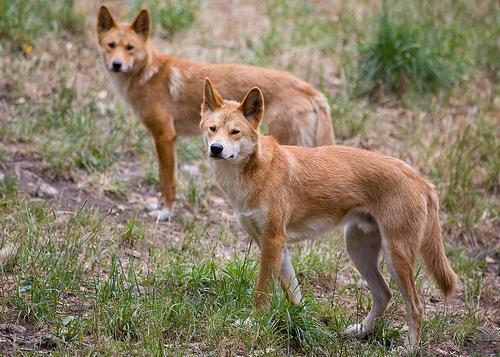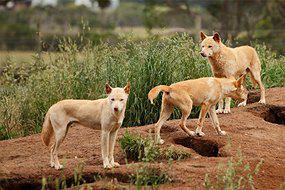The first image is the image on the left, the second image is the image on the right. Analyze the images presented: Is the assertion "There are exactly three canines in the right image." valid? Answer yes or no. Yes. The first image is the image on the left, the second image is the image on the right. For the images displayed, is the sentence "The left image contains exactly two canines." factually correct? Answer yes or no. Yes. 